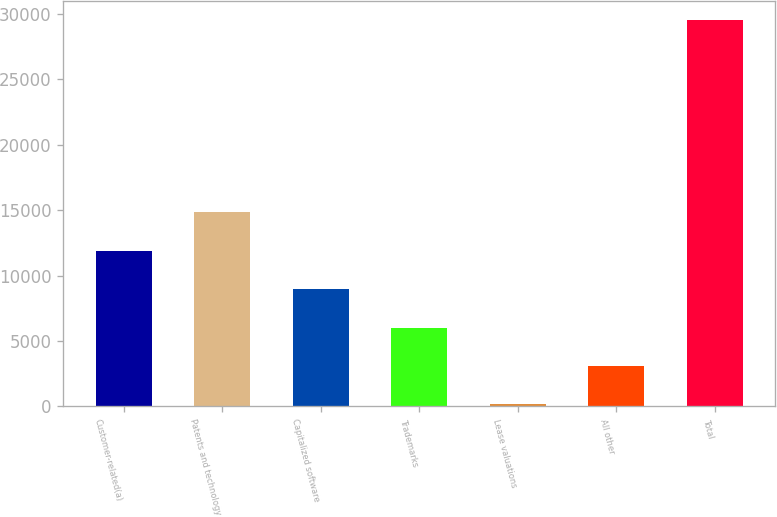Convert chart. <chart><loc_0><loc_0><loc_500><loc_500><bar_chart><fcel>Customer-related(a)<fcel>Patents and technology<fcel>Capitalized software<fcel>Trademarks<fcel>Lease valuations<fcel>All other<fcel>Total<nl><fcel>11895.2<fcel>14831.5<fcel>8958.9<fcel>6022.6<fcel>150<fcel>3086.3<fcel>29513<nl></chart> 